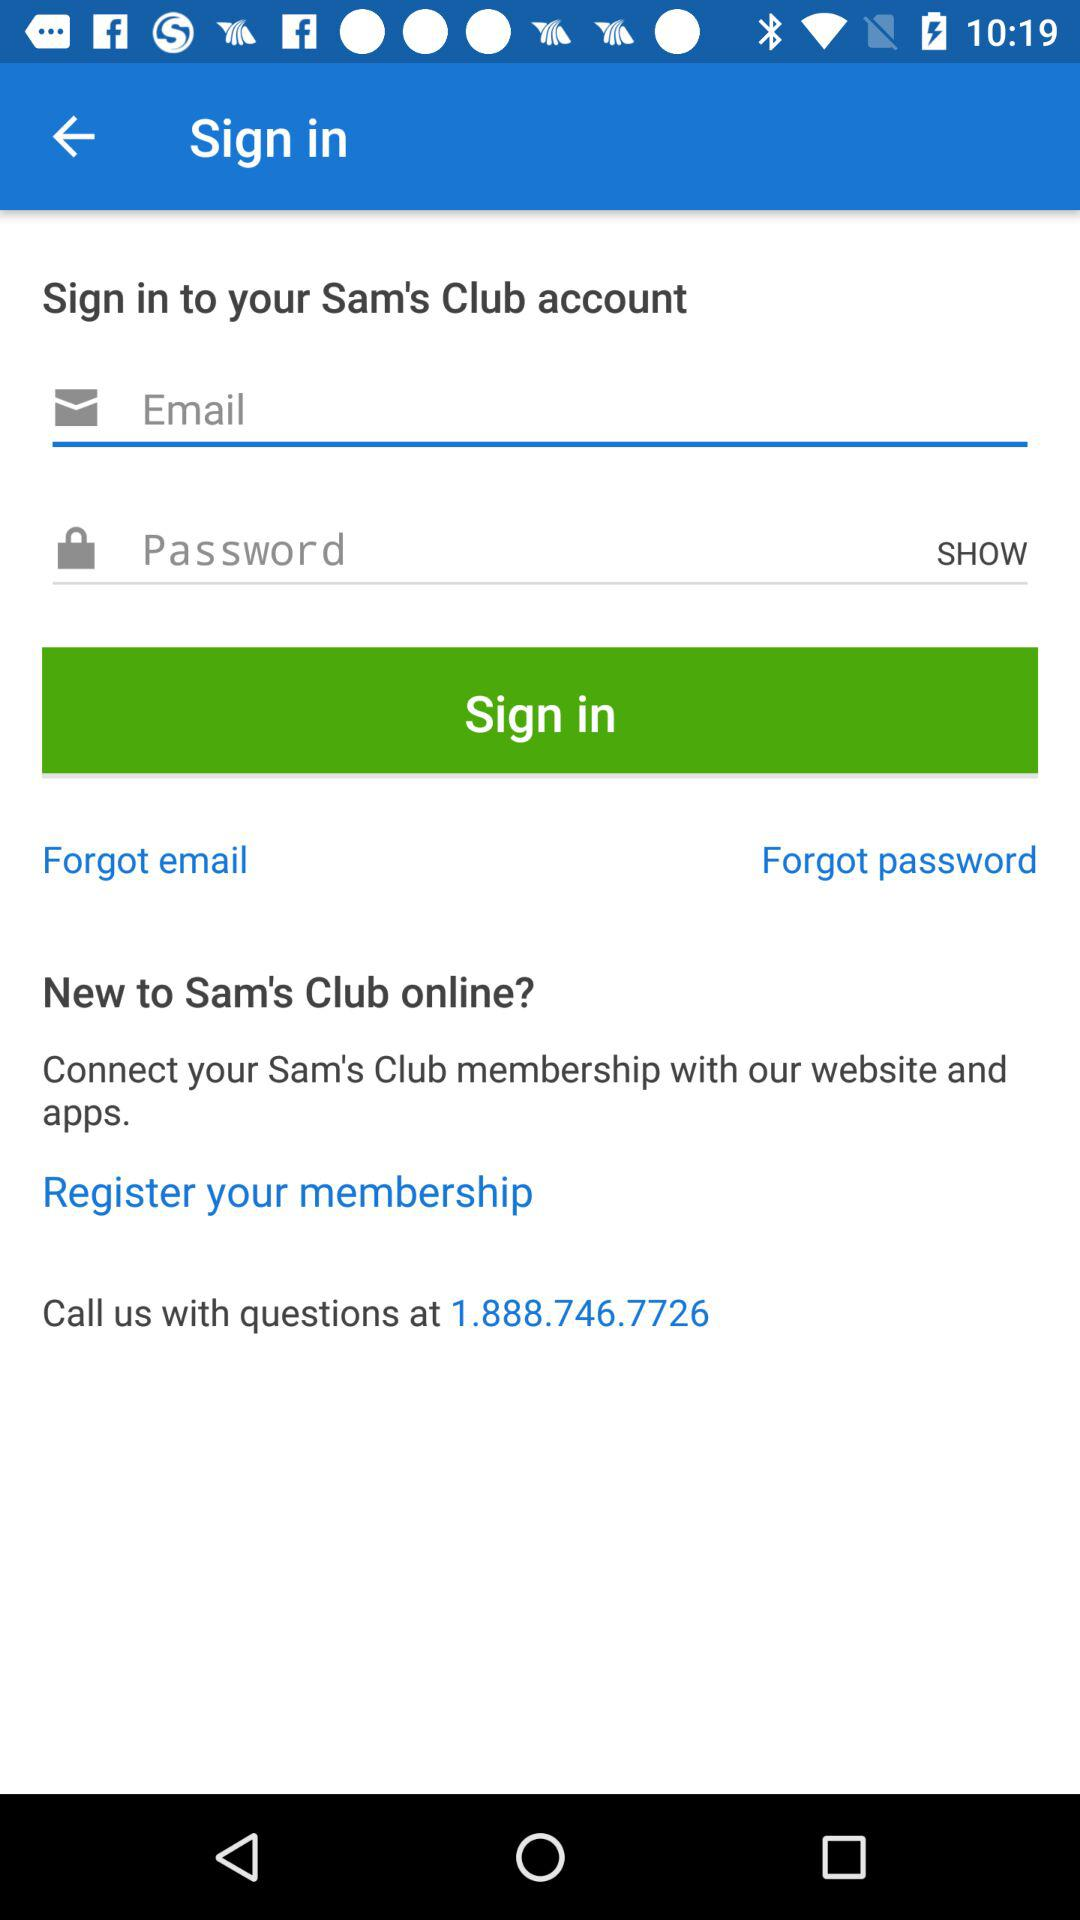How long must a password be?
When the provided information is insufficient, respond with <no answer>. <no answer> 